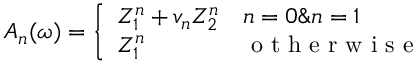<formula> <loc_0><loc_0><loc_500><loc_500>A _ { n } ( \omega ) = \left \{ \begin{array} { l l } { Z _ { 1 } ^ { n } + v _ { n } Z _ { 2 } ^ { n } } & { n = 0 \& n = 1 } \\ { Z _ { 1 } ^ { n } } & { o t h e r w i s e } \end{array}</formula> 